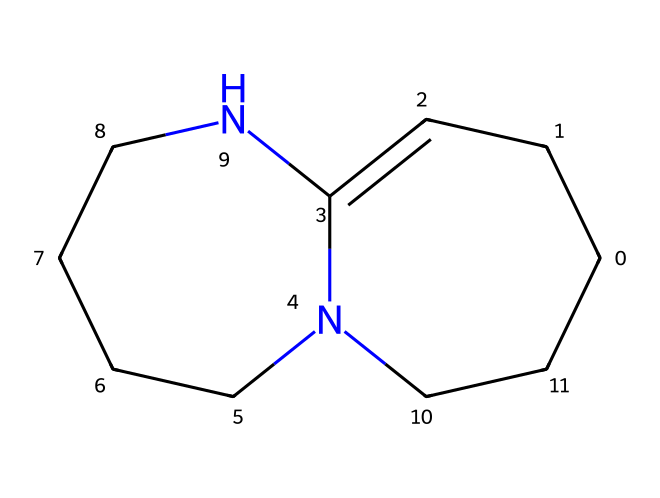What is the overall molecular formula for 1,8-diazabicyclo[5.4.0]undec-7-ene (DBU)? To find the molecular formula, we need to count the number of carbon (C), hydrogen (H), and nitrogen (N) atoms in the structure from the SMILES representation. By analyzing the structure, we find there are 11 carbon atoms, 16 hydrogen atoms, and 2 nitrogen atoms. Therefore, the molecular formula is C11H16N2.
Answer: C11H16N2 How many nitrogen atoms are present in DBU? The SMILES representation indicates the presence of two nitrogen atoms (N), which can be directly observed in the structure.
Answer: 2 What type of hybridization is present at the nitrogen atoms in DBU? Analyzing the connectivity and surrounding atoms, the nitrogen atoms are connected to two carbon atoms and one lone pair, indicating sp2 hybridization. This is evident as they are part of a bicyclic structure, contributing to a double bond.
Answer: sp2 Why is DBU considered a superbase? DBU is classified as a superbase due to its ability to deprotonate weak acids. This is a result of the stability provided by the bicyclic ring structure and the presence of nitrogen atoms that can effectively stabilize a negative charge.
Answer: deprotonation What type of reaction is DBU typically used for in pharmaceutical synthesis? DBU is commonly utilized in nucleophilic reactions, particularly in the formation of new carbon-carbon and carbon-nitrogen bonds within synthetic pathways in pharmaceuticals.
Answer: nucleophilic reactions Identify one physical property that distinguishes DBU from weak bases. DBU has a relatively high basicity, which is a significant property differentiating it from weaker bases, thereby making it suitable for promoting reactions that require stronger bases.
Answer: high basicity 